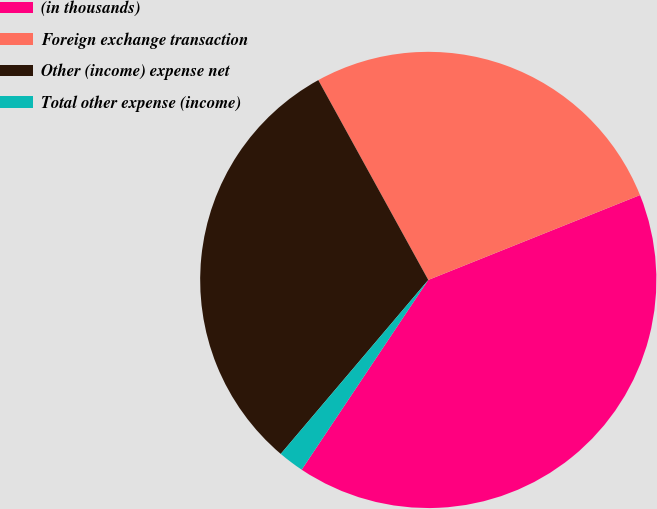Convert chart. <chart><loc_0><loc_0><loc_500><loc_500><pie_chart><fcel>(in thousands)<fcel>Foreign exchange transaction<fcel>Other (income) expense net<fcel>Total other expense (income)<nl><fcel>40.43%<fcel>26.94%<fcel>30.8%<fcel>1.83%<nl></chart> 